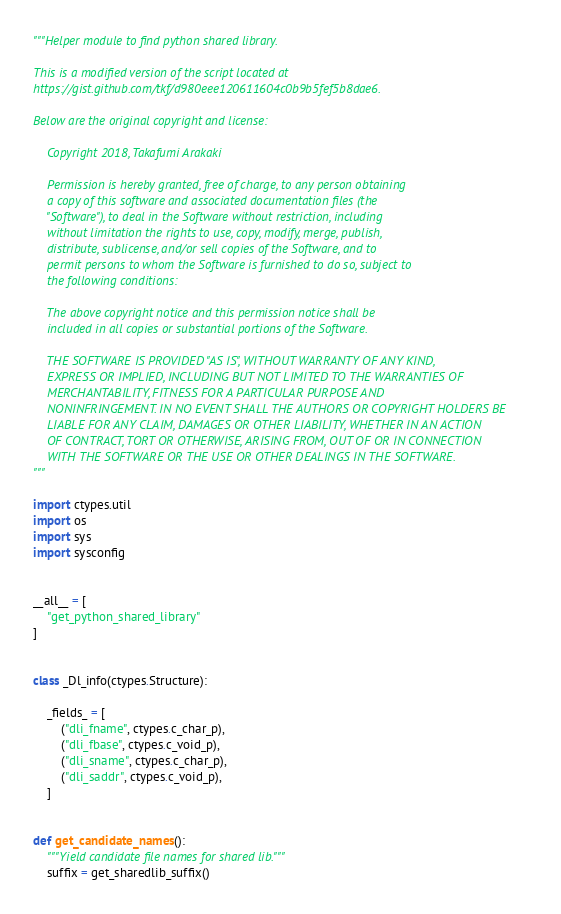<code> <loc_0><loc_0><loc_500><loc_500><_Python_>"""Helper module to find python shared library.

This is a modified version of the script located at
https://gist.github.com/tkf/d980eee120611604c0b9b5fef5b8dae6.

Below are the original copyright and license:

    Copyright 2018, Takafumi Arakaki

    Permission is hereby granted, free of charge, to any person obtaining
    a copy of this software and associated documentation files (the
    "Software"), to deal in the Software without restriction, including
    without limitation the rights to use, copy, modify, merge, publish,
    distribute, sublicense, and/or sell copies of the Software, and to
    permit persons to whom the Software is furnished to do so, subject to
    the following conditions:

    The above copyright notice and this permission notice shall be
    included in all copies or substantial portions of the Software.

    THE SOFTWARE IS PROVIDED "AS IS", WITHOUT WARRANTY OF ANY KIND,
    EXPRESS OR IMPLIED, INCLUDING BUT NOT LIMITED TO THE WARRANTIES OF
    MERCHANTABILITY, FITNESS FOR A PARTICULAR PURPOSE AND
    NONINFRINGEMENT. IN NO EVENT SHALL THE AUTHORS OR COPYRIGHT HOLDERS BE
    LIABLE FOR ANY CLAIM, DAMAGES OR OTHER LIABILITY, WHETHER IN AN ACTION
    OF CONTRACT, TORT OR OTHERWISE, ARISING FROM, OUT OF OR IN CONNECTION
    WITH THE SOFTWARE OR THE USE OR OTHER DEALINGS IN THE SOFTWARE.
"""

import ctypes.util
import os
import sys
import sysconfig


__all__ = [
    "get_python_shared_library"
]


class _Dl_info(ctypes.Structure):

    _fields_ = [
        ("dli_fname", ctypes.c_char_p),
        ("dli_fbase", ctypes.c_void_p),
        ("dli_sname", ctypes.c_char_p),
        ("dli_saddr", ctypes.c_void_p),
    ]


def get_candidate_names():
    """Yield candidate file names for shared lib."""
    suffix = get_sharedlib_suffix()</code> 